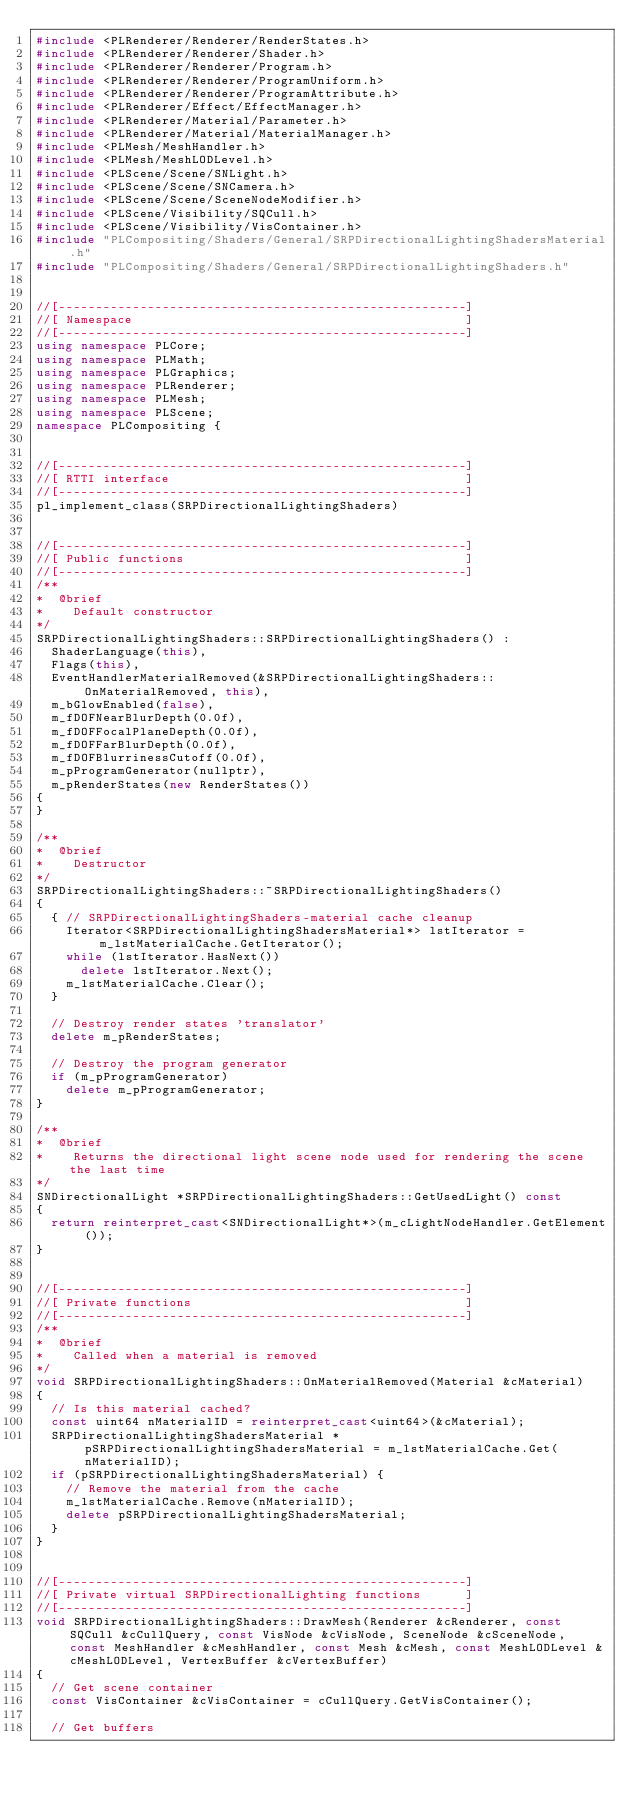Convert code to text. <code><loc_0><loc_0><loc_500><loc_500><_C++_>#include <PLRenderer/Renderer/RenderStates.h>
#include <PLRenderer/Renderer/Shader.h>
#include <PLRenderer/Renderer/Program.h>
#include <PLRenderer/Renderer/ProgramUniform.h>
#include <PLRenderer/Renderer/ProgramAttribute.h>
#include <PLRenderer/Effect/EffectManager.h>
#include <PLRenderer/Material/Parameter.h>
#include <PLRenderer/Material/MaterialManager.h>
#include <PLMesh/MeshHandler.h>
#include <PLMesh/MeshLODLevel.h>
#include <PLScene/Scene/SNLight.h>
#include <PLScene/Scene/SNCamera.h>
#include <PLScene/Scene/SceneNodeModifier.h>
#include <PLScene/Visibility/SQCull.h>
#include <PLScene/Visibility/VisContainer.h>
#include "PLCompositing/Shaders/General/SRPDirectionalLightingShadersMaterial.h"
#include "PLCompositing/Shaders/General/SRPDirectionalLightingShaders.h"


//[-------------------------------------------------------]
//[ Namespace                                             ]
//[-------------------------------------------------------]
using namespace PLCore;
using namespace PLMath;
using namespace PLGraphics;
using namespace PLRenderer;
using namespace PLMesh;
using namespace PLScene;
namespace PLCompositing {


//[-------------------------------------------------------]
//[ RTTI interface                                        ]
//[-------------------------------------------------------]
pl_implement_class(SRPDirectionalLightingShaders)


//[-------------------------------------------------------]
//[ Public functions                                      ]
//[-------------------------------------------------------]
/**
*  @brief
*    Default constructor
*/
SRPDirectionalLightingShaders::SRPDirectionalLightingShaders() :
	ShaderLanguage(this),
	Flags(this),
	EventHandlerMaterialRemoved(&SRPDirectionalLightingShaders::OnMaterialRemoved, this),
	m_bGlowEnabled(false),
	m_fDOFNearBlurDepth(0.0f),
	m_fDOFFocalPlaneDepth(0.0f),
	m_fDOFFarBlurDepth(0.0f),
	m_fDOFBlurrinessCutoff(0.0f),
	m_pProgramGenerator(nullptr),
	m_pRenderStates(new RenderStates())
{
}

/**
*  @brief
*    Destructor
*/
SRPDirectionalLightingShaders::~SRPDirectionalLightingShaders()
{
	{ // SRPDirectionalLightingShaders-material cache cleanup
		Iterator<SRPDirectionalLightingShadersMaterial*> lstIterator = m_lstMaterialCache.GetIterator();
		while (lstIterator.HasNext())
			delete lstIterator.Next();
		m_lstMaterialCache.Clear();
	}

	// Destroy render states 'translator'
	delete m_pRenderStates;

	// Destroy the program generator
	if (m_pProgramGenerator)
		delete m_pProgramGenerator;
}

/**
*  @brief
*    Returns the directional light scene node used for rendering the scene the last time
*/
SNDirectionalLight *SRPDirectionalLightingShaders::GetUsedLight() const
{
	return reinterpret_cast<SNDirectionalLight*>(m_cLightNodeHandler.GetElement());
}


//[-------------------------------------------------------]
//[ Private functions                                     ]
//[-------------------------------------------------------]
/**
*  @brief
*    Called when a material is removed
*/
void SRPDirectionalLightingShaders::OnMaterialRemoved(Material &cMaterial)
{
	// Is this material cached?
	const uint64 nMaterialID = reinterpret_cast<uint64>(&cMaterial);
	SRPDirectionalLightingShadersMaterial *pSRPDirectionalLightingShadersMaterial = m_lstMaterialCache.Get(nMaterialID);
	if (pSRPDirectionalLightingShadersMaterial) {
		// Remove the material from the cache
		m_lstMaterialCache.Remove(nMaterialID);
		delete pSRPDirectionalLightingShadersMaterial;
	}
}


//[-------------------------------------------------------]
//[ Private virtual SRPDirectionalLighting functions      ]
//[-------------------------------------------------------]
void SRPDirectionalLightingShaders::DrawMesh(Renderer &cRenderer, const SQCull &cCullQuery, const VisNode &cVisNode, SceneNode &cSceneNode, const MeshHandler &cMeshHandler, const Mesh &cMesh, const MeshLODLevel &cMeshLODLevel, VertexBuffer &cVertexBuffer)
{
	// Get scene container
	const VisContainer &cVisContainer = cCullQuery.GetVisContainer();

	// Get buffers</code> 